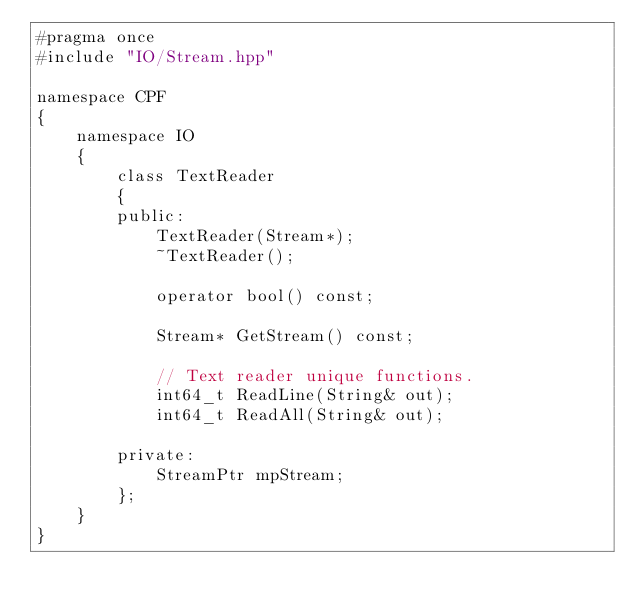Convert code to text. <code><loc_0><loc_0><loc_500><loc_500><_C++_>#pragma once
#include "IO/Stream.hpp"

namespace CPF
{
	namespace IO
	{
		class TextReader
		{
		public:
			TextReader(Stream*);
			~TextReader();

			operator bool() const;

			Stream* GetStream() const;

			// Text reader unique functions.
			int64_t ReadLine(String& out);
			int64_t ReadAll(String& out);

		private:
			StreamPtr mpStream;
		};
	}
}
</code> 